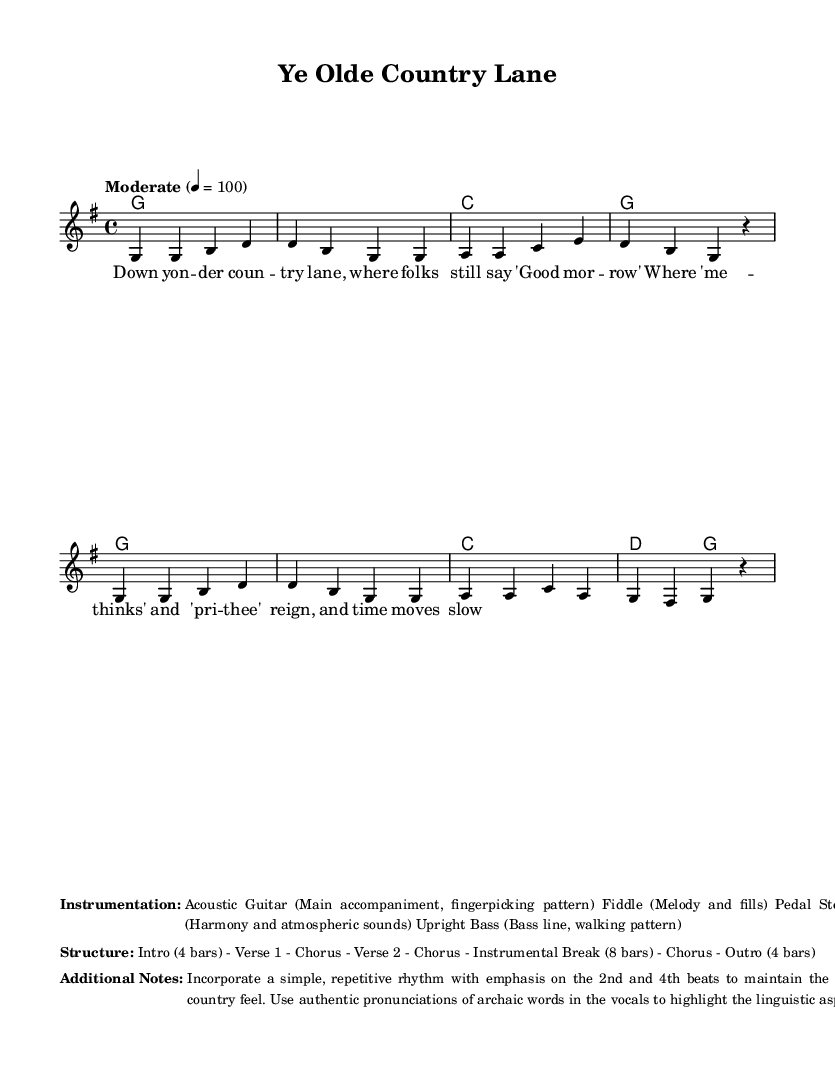What is the key signature of this music? The key signature is G major, which features one sharp (F#). This can be confirmed by examining the key signature symbol placed at the beginning of the sheet music.
Answer: G major What is the time signature of this piece? The time signature given at the start of the music is 4/4, as indicated by the notation at the beginning of the score. This means there are four beats per measure, with a quarter note receiving one beat.
Answer: 4/4 What is the tempo marking for this composition? The tempo marking states "Moderate" and indicates a speed of 4 = 100, meaning there should be 100 quarter notes played per minute. This can be directly found in the tempo section of the score.
Answer: 100 How many measures are there in the melody? The melody consists of a total of eight measures, which can be counted by looking at the measure lines in the melody section. Each group of notes separated by vertical lines constitutes one measure.
Answer: 8 What instruments are included in the arrangement? The instrumentation listed includes Acoustic Guitar, Fiddle, Pedal Steel Guitar, and Upright Bass. This information is found in the marked section regarding instrumentation.
Answer: Acoustic Guitar, Fiddle, Pedal Steel Guitar, Upright Bass What key aspect of traditional country lyrics is emphasized in this piece? The piece emphasizes authentic pronunciations of archaic words, as noted in the additional notes section. This showcases the linguistic element that connects the musical content to its traditional roots.
Answer: Archaic words 